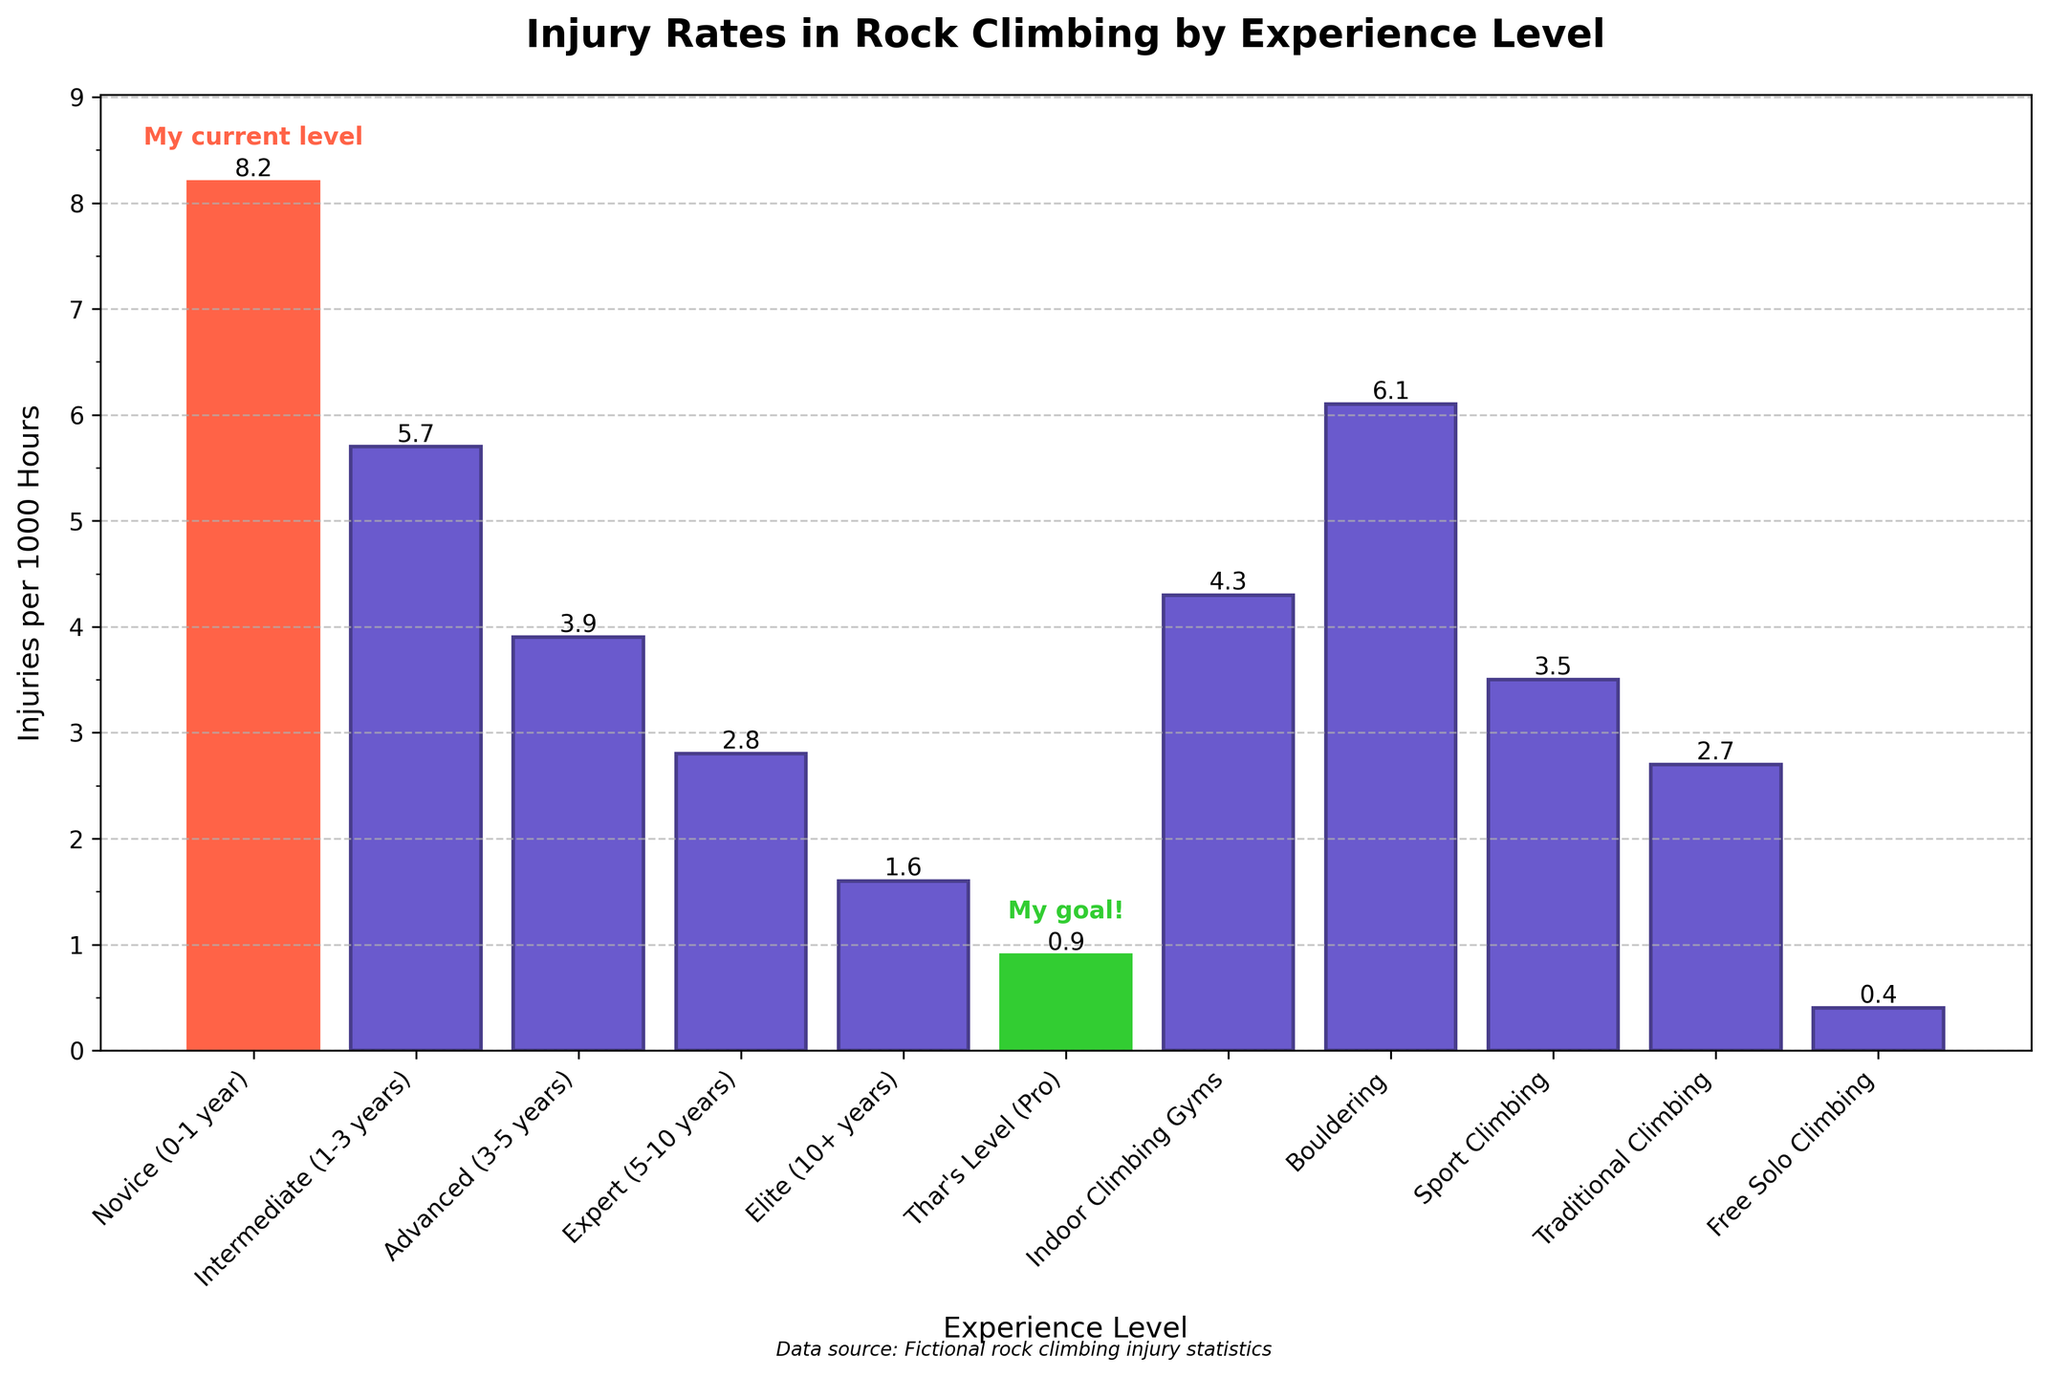Which experience level has the highest injury rate? The bar for "Novice (0-1 year)" is the tallest among all categories, indicating that this experience level has the highest injury rate.
Answer: Novice (0-1 year) Which experience level has the lowest injury rate? "Free Solo Climbing" has the shortest bar, indicating the lowest injury rate among all the categories.
Answer: Free Solo Climbing How much higher is the injury rate for novices compared to intermediates? Novices have an injury rate of 8.2 per 1000 hours, while intermediates have 5.7. The difference is calculated as 8.2 - 5.7 = 2.5.
Answer: 2.5 What is the average injury rate for the "Novice", "Intermediate", and "Advanced" levels? The injury rates are Novice: 8.2, Intermediate: 5.7, Advanced: 3.9. The average is calculated as (8.2 + 5.7 + 3.9) / 3 ≈ 5.93.
Answer: 5.93 Is the injury rate for indoor climbing gyms higher or lower than for sport climbing? The injury rate for indoor climbing gyms is 4.3, and for sport climbing, it is 3.5. Thus, the injury rate for indoor climbing gyms is higher.
Answer: Higher By how much is Thar's level injury rate lower than the elite level? Thar's level has an injury rate of 0.9, while the elite level has 1.6. The difference is 1.6 - 0.9 = 0.7.
Answer: 0.7 Between which two experience levels is the biggest drop in injury rate observed? By inspecting the bar heights, the biggest drop is between "Novice (0-1 year)" at 8.2 and "Intermediate (1-3 years)" at 5.7.
Answer: Novice to Intermediate What is the combined injury rate for "Novice" and "Thar's Level"? Adding the injury rates of Novice (8.2) and Thar's Level (0.9): 8.2 + 0.9 = 9.1.
Answer: 9.1 Which climbing type has the second-highest injury rate? After "Novice (0-1 year)" (8.2) in overall data, "Bouldering" has the second-highest bar at 6.1 among all activities.
Answer: Bouldering 